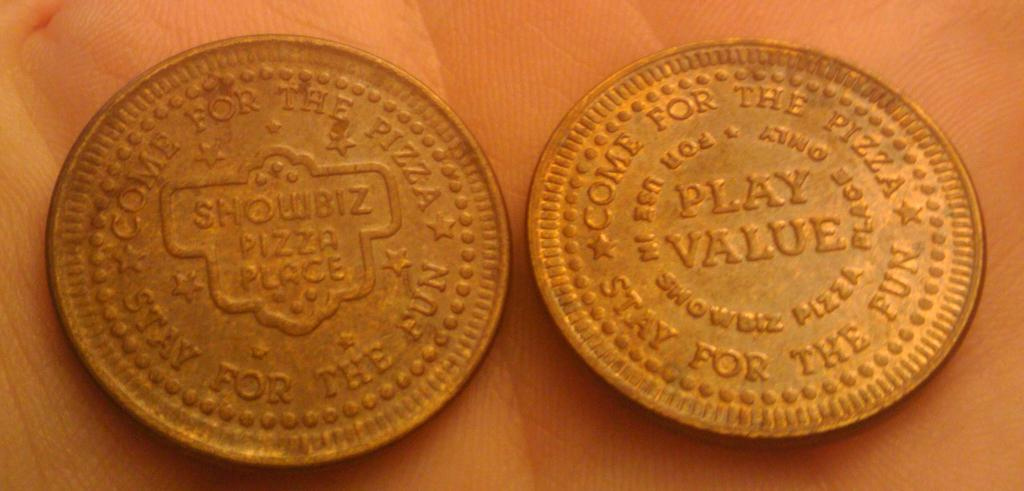<image>
Share a concise interpretation of the image provided. Two Showbiz Pizza Place tokens are in someone's hand. 